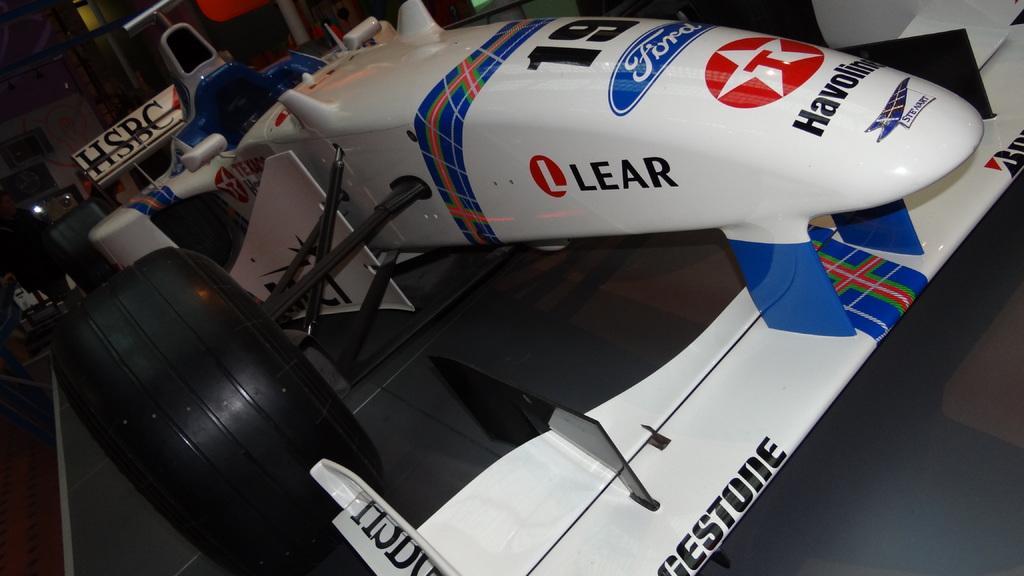How would you summarize this image in a sentence or two? In this image there is a blue and white color go- kart race car with a name board HSBC , and in the background there are some objects. 